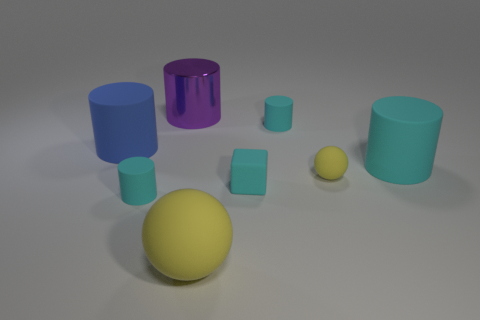What is the size of the metallic cylinder?
Give a very brief answer. Large. Do the blue matte thing and the matte cylinder that is in front of the large cyan cylinder have the same size?
Give a very brief answer. No. What number of yellow objects are either balls or matte objects?
Provide a succinct answer. 2. How many big blue cylinders are there?
Your answer should be very brief. 1. There is a cyan thing left of the large purple object; how big is it?
Offer a terse response. Small. Is the size of the purple metallic object the same as the cyan block?
Ensure brevity in your answer.  No. How many things are small matte blocks or small cyan cylinders that are in front of the matte cube?
Your answer should be very brief. 2. What is the material of the big purple object?
Provide a short and direct response. Metal. Is there anything else of the same color as the tiny matte sphere?
Provide a short and direct response. Yes. Does the blue object have the same shape as the large cyan rubber object?
Give a very brief answer. Yes. 